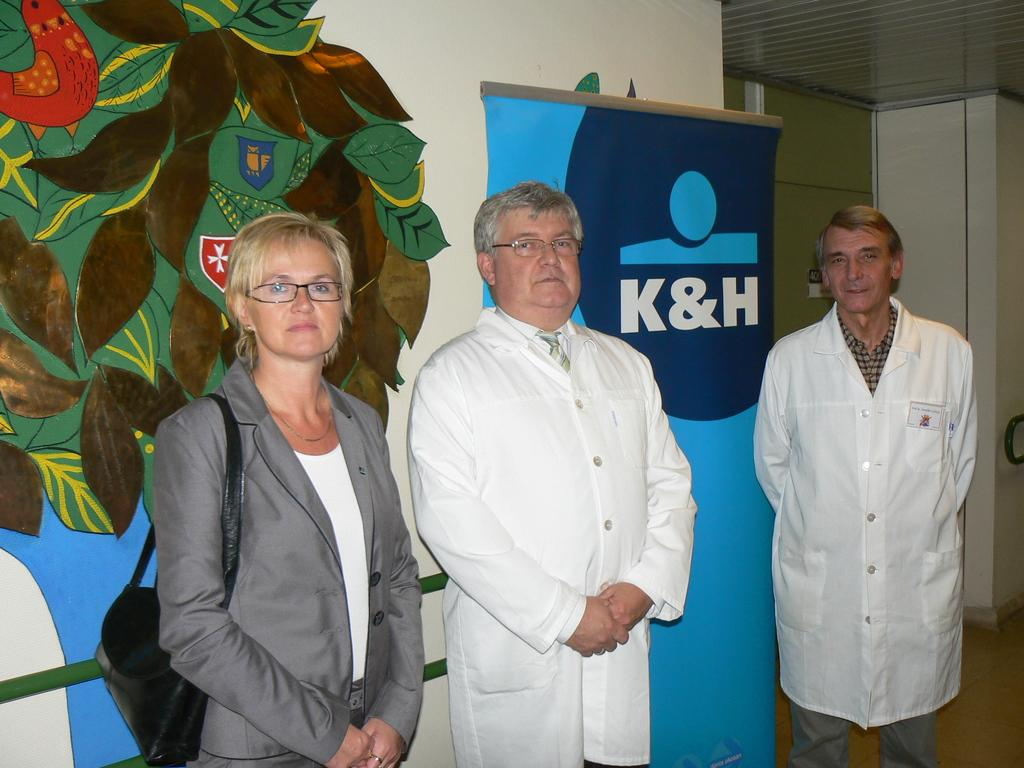Who or what can be seen in the image? There are people in the image. What is on the wall in the image? There is a wall with a poster in the image. What is written or depicted on the poster? There is text on the poster. What type of visual content is present in the image? There is art in the image. What architectural features can be seen in the image? There are doors in the image. What part of a building is visible in the image? The roof is visible in the image. What type of trail can be seen in the image? There is no trail present in the image. What is the mouth of the person in the image doing? There is no person with a mouth visible in the image. 